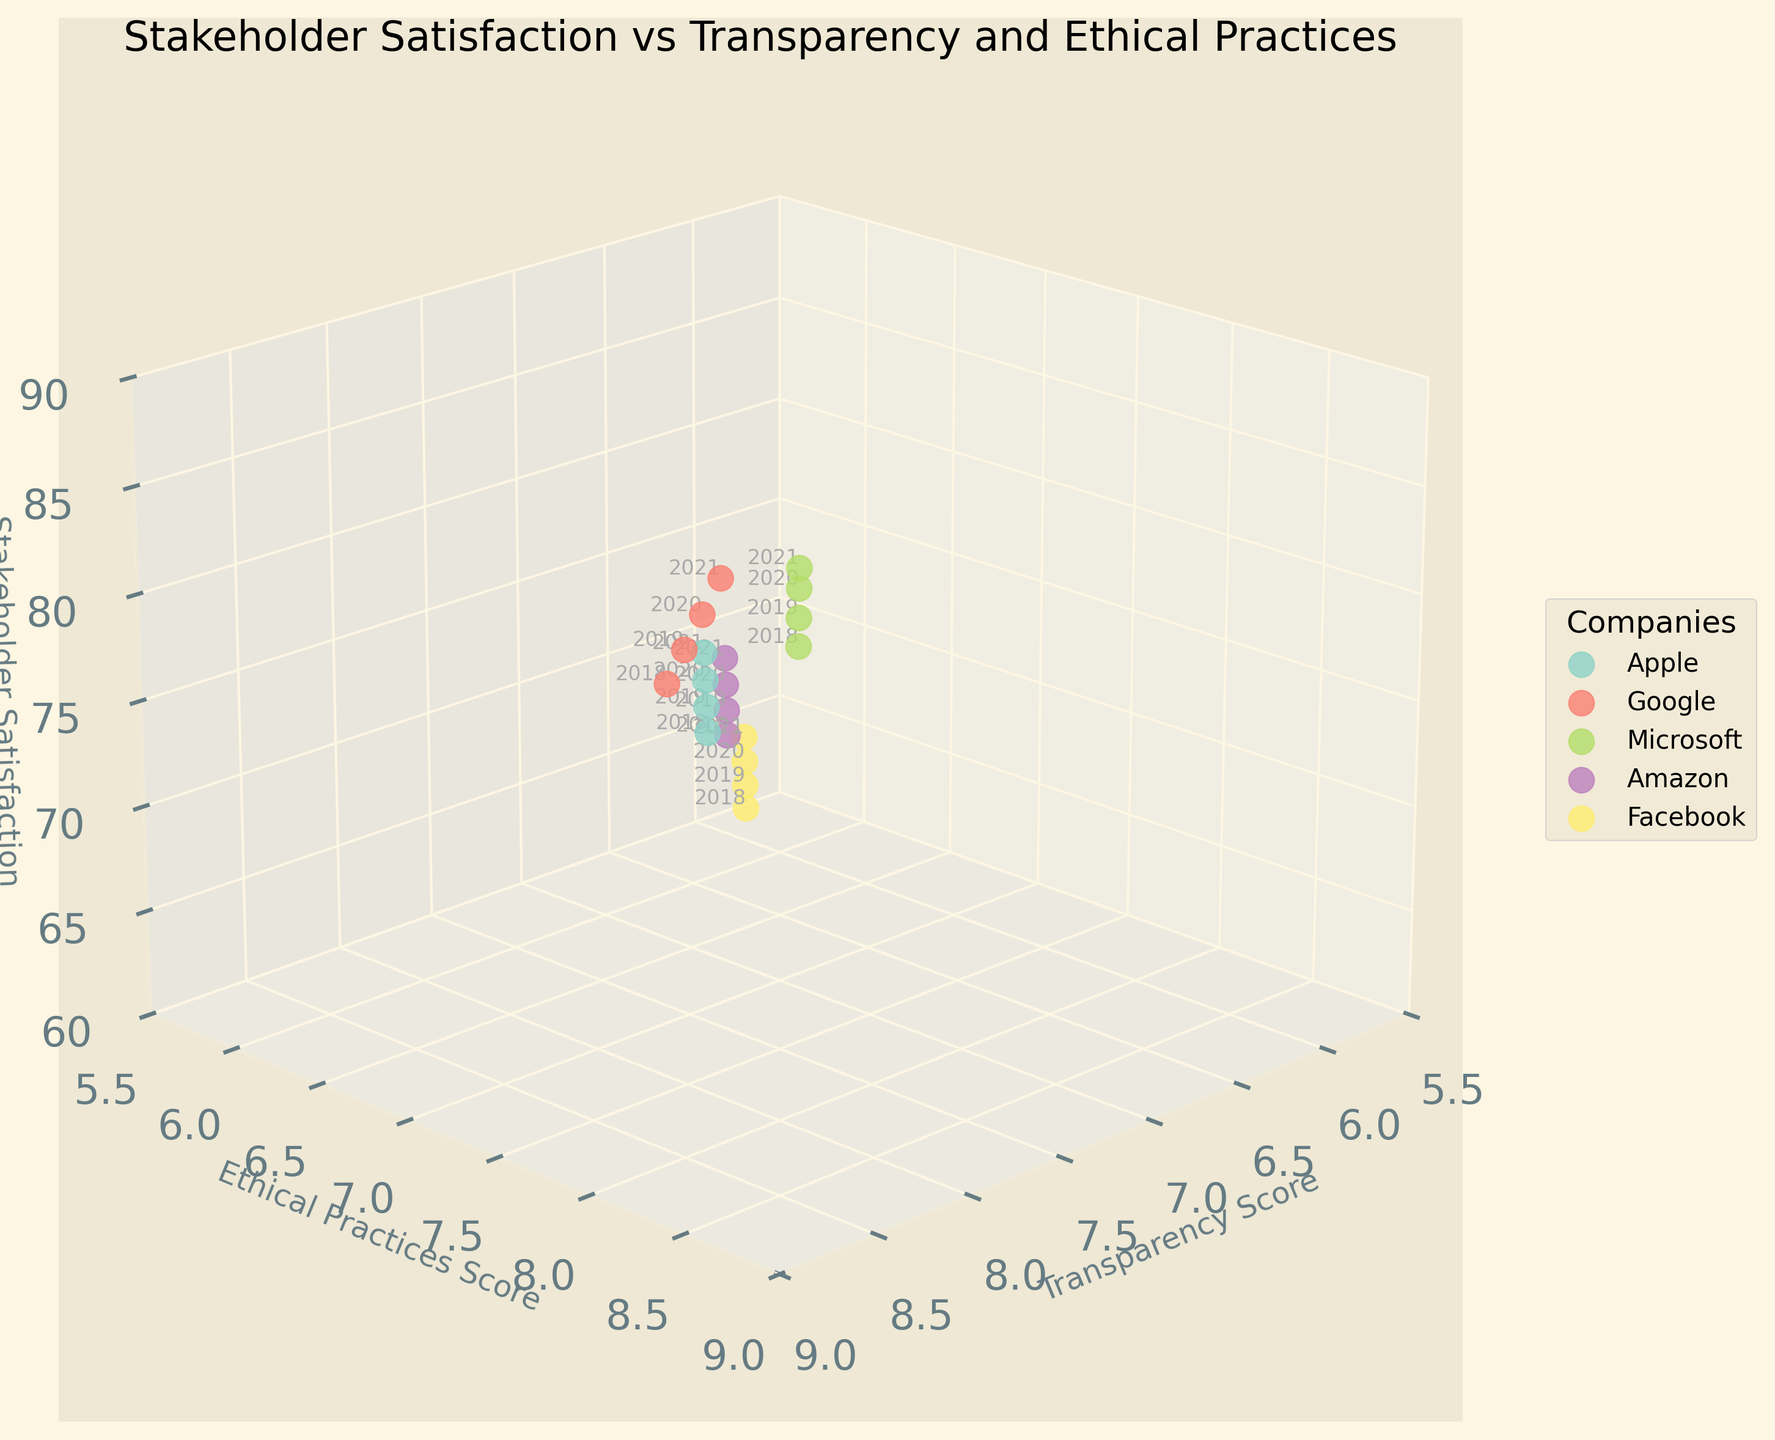What is the title of the plot? The title can be found at the top of the plot, typically in larger font. The title is used to provide a summary of what the plot represents.
Answer: Stakeholder Satisfaction vs Transparency and Ethical Practices What is the z-axis label in the plot? The z-axis label is located next to the z-axis and indicates what metric is being measured along that dimension. In this plot, it's related to the satisfaction level of stakeholders.
Answer: Stakeholder Satisfaction Which company had the highest Stakeholder Satisfaction score in 2021? To find this, locate the year 2021 data points and compare the z-axis (Stakeholder Satisfaction) values for each company. The highest point represents the highest score.
Answer: Microsoft How did Facebook's Stakeholder Satisfaction score change from 2018 to 2021? Track Facebook's Stakeholder Satisfaction scores over the years 2018 to 2021 by looking at the z-axis values for Facebook in 2018 and 2021. Compare these values to determine the change.
Answer: Increased from 61 to 70 Which company showed the largest improvement in both Transparency Score and Ethical Practices Score from 2018 to 2021? For each company, compare the 2018 and 2021 Transparency and Ethical Practices scores. Calculate the difference for both scores and identify the company with the largest combined increase.
Answer: Google Between Apple and Amazon, which company had a higher average Stakeholder Satisfaction score from 2018 to 2021? Calculate the average Stakeholder Satisfaction score for Apple and Amazon over the years 2018 to 2021. Compare these averages to determine which company had the higher value.
Answer: Apple Which year did Google have the highest Transparency Score, and what was the score? Identify the peak Transparency Score for Google by reviewing the data points over the years and noting the year associated with the highest score.
Answer: 2021, 8.7 Is there a visible correlation between Transparency Scores and Stakeholder Satisfaction in the plot? To determine the correlation, observe the relationship between the x-axis (Transparency Scores) and the z-axis (Stakeholder Satisfaction). A positive correlation would show higher Transparency Scores aligning with higher Stakeholder Satisfaction.
Answer: Yes, generally positive 